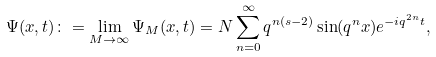<formula> <loc_0><loc_0><loc_500><loc_500>\Psi ( x , t ) \colon = \lim _ { M \rightarrow \infty } \Psi _ { M } ( x , t ) = N \sum _ { n = 0 } ^ { \infty } q ^ { n ( s - 2 ) } \sin ( q ^ { n } x ) e ^ { - i q ^ { 2 n } t } ,</formula> 